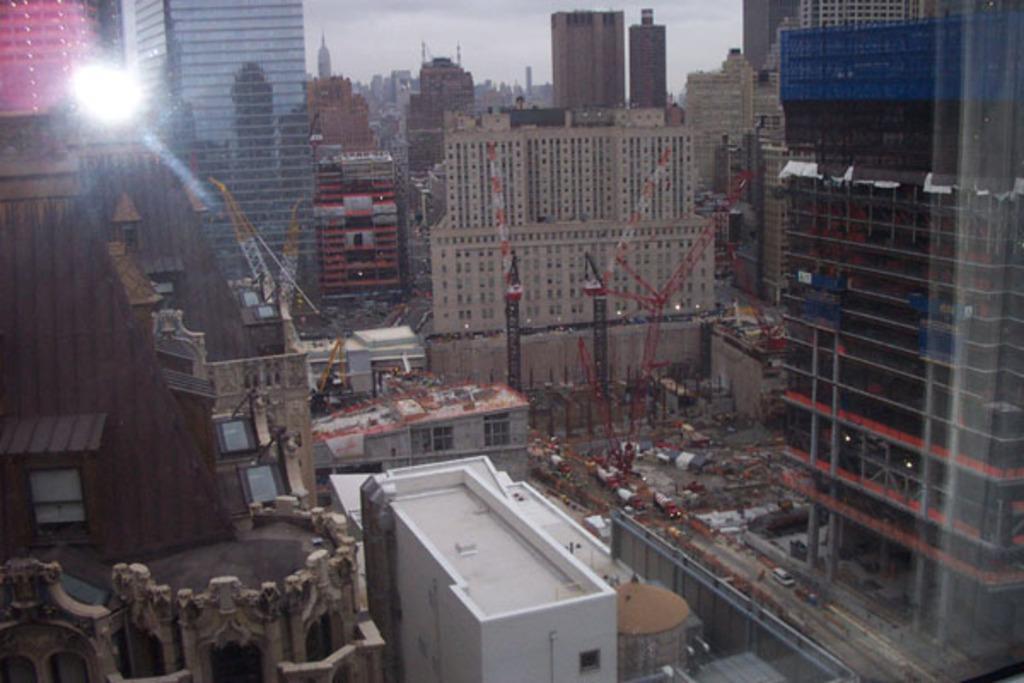Please provide a concise description of this image. On the right side there is a building with pillars. Near to that there is a building with many vehicles and cranes. In the back there are many buildings. Also on the top left corner there is light. 